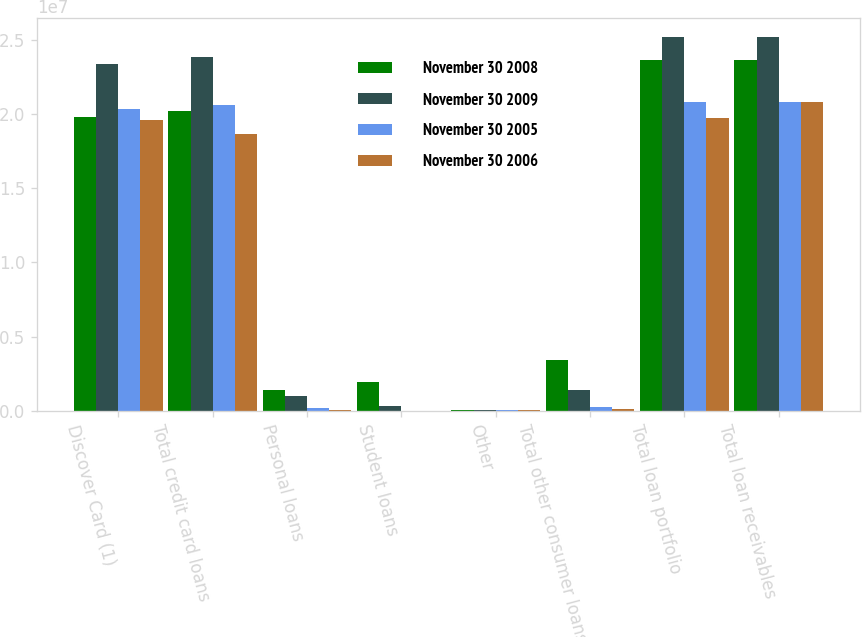Convert chart. <chart><loc_0><loc_0><loc_500><loc_500><stacked_bar_chart><ecel><fcel>Discover Card (1)<fcel>Total credit card loans<fcel>Personal loans<fcel>Student loans<fcel>Other<fcel>Total other consumer loans<fcel>Total loan portfolio<fcel>Total loan receivables<nl><fcel>November 30 2008<fcel>1.98262e+07<fcel>2.02303e+07<fcel>1.39438e+06<fcel>1.93227e+06<fcel>68137<fcel>3.39478e+06<fcel>2.36251e+07<fcel>2.36251e+07<nl><fcel>November 30 2009<fcel>2.33481e+07<fcel>2.38143e+07<fcel>1.02809e+06<fcel>299929<fcel>74282<fcel>1.4023e+06<fcel>2.52166e+07<fcel>2.52166e+07<nl><fcel>November 30 2005<fcel>2.03458e+07<fcel>2.05799e+07<fcel>165529<fcel>12820<fcel>72845<fcel>251194<fcel>2.08311e+07<fcel>2.08311e+07<nl><fcel>November 30 2006<fcel>1.95827e+07<fcel>1.86418e+07<fcel>24968<fcel>155<fcel>66978<fcel>92101<fcel>1.97339e+07<fcel>2.07902e+07<nl></chart> 